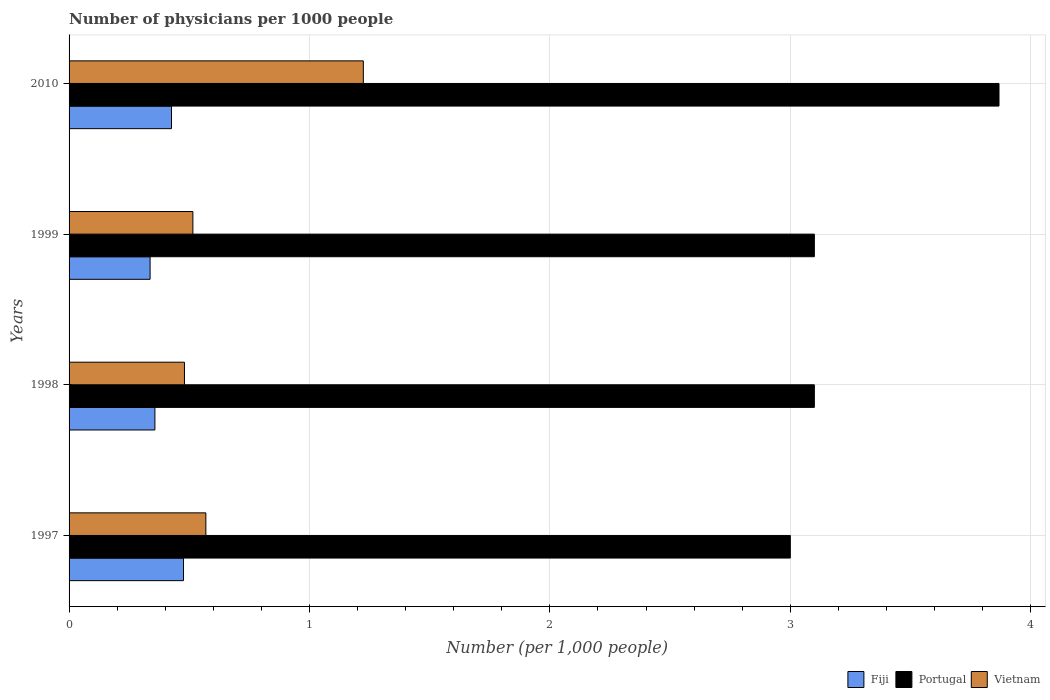How many bars are there on the 4th tick from the top?
Provide a succinct answer. 3. What is the label of the 3rd group of bars from the top?
Your answer should be compact. 1998. In how many cases, is the number of bars for a given year not equal to the number of legend labels?
Give a very brief answer. 0. What is the number of physicians in Vietnam in 2010?
Offer a very short reply. 1.22. Across all years, what is the maximum number of physicians in Portugal?
Your response must be concise. 3.87. Across all years, what is the minimum number of physicians in Fiji?
Your answer should be very brief. 0.34. In which year was the number of physicians in Portugal maximum?
Provide a succinct answer. 2010. What is the total number of physicians in Vietnam in the graph?
Keep it short and to the point. 2.79. What is the difference between the number of physicians in Fiji in 1999 and that in 2010?
Keep it short and to the point. -0.09. What is the difference between the number of physicians in Portugal in 1998 and the number of physicians in Fiji in 1999?
Provide a short and direct response. 2.76. What is the average number of physicians in Vietnam per year?
Provide a succinct answer. 0.7. In the year 2010, what is the difference between the number of physicians in Portugal and number of physicians in Fiji?
Provide a succinct answer. 3.44. What is the ratio of the number of physicians in Fiji in 1997 to that in 2010?
Give a very brief answer. 1.12. Is the number of physicians in Portugal in 1998 less than that in 2010?
Your answer should be very brief. Yes. What is the difference between the highest and the second highest number of physicians in Fiji?
Make the answer very short. 0.05. What is the difference between the highest and the lowest number of physicians in Portugal?
Your answer should be very brief. 0.87. Is the sum of the number of physicians in Vietnam in 1998 and 2010 greater than the maximum number of physicians in Portugal across all years?
Keep it short and to the point. No. What does the 3rd bar from the top in 1999 represents?
Offer a terse response. Fiji. What does the 1st bar from the bottom in 1999 represents?
Provide a succinct answer. Fiji. Is it the case that in every year, the sum of the number of physicians in Fiji and number of physicians in Vietnam is greater than the number of physicians in Portugal?
Keep it short and to the point. No. How many bars are there?
Provide a short and direct response. 12. What is the difference between two consecutive major ticks on the X-axis?
Provide a succinct answer. 1. Where does the legend appear in the graph?
Your answer should be very brief. Bottom right. What is the title of the graph?
Give a very brief answer. Number of physicians per 1000 people. Does "Latvia" appear as one of the legend labels in the graph?
Offer a very short reply. No. What is the label or title of the X-axis?
Keep it short and to the point. Number (per 1,0 people). What is the label or title of the Y-axis?
Keep it short and to the point. Years. What is the Number (per 1,000 people) of Fiji in 1997?
Provide a succinct answer. 0.48. What is the Number (per 1,000 people) of Portugal in 1997?
Offer a terse response. 3. What is the Number (per 1,000 people) of Vietnam in 1997?
Provide a short and direct response. 0.57. What is the Number (per 1,000 people) in Fiji in 1998?
Provide a short and direct response. 0.36. What is the Number (per 1,000 people) of Portugal in 1998?
Ensure brevity in your answer.  3.1. What is the Number (per 1,000 people) of Vietnam in 1998?
Make the answer very short. 0.48. What is the Number (per 1,000 people) in Fiji in 1999?
Your answer should be compact. 0.34. What is the Number (per 1,000 people) in Portugal in 1999?
Offer a very short reply. 3.1. What is the Number (per 1,000 people) of Vietnam in 1999?
Offer a very short reply. 0.52. What is the Number (per 1,000 people) of Fiji in 2010?
Ensure brevity in your answer.  0.43. What is the Number (per 1,000 people) of Portugal in 2010?
Make the answer very short. 3.87. What is the Number (per 1,000 people) in Vietnam in 2010?
Your answer should be compact. 1.22. Across all years, what is the maximum Number (per 1,000 people) in Fiji?
Keep it short and to the point. 0.48. Across all years, what is the maximum Number (per 1,000 people) of Portugal?
Your answer should be very brief. 3.87. Across all years, what is the maximum Number (per 1,000 people) in Vietnam?
Make the answer very short. 1.22. Across all years, what is the minimum Number (per 1,000 people) in Fiji?
Give a very brief answer. 0.34. Across all years, what is the minimum Number (per 1,000 people) of Vietnam?
Give a very brief answer. 0.48. What is the total Number (per 1,000 people) in Fiji in the graph?
Offer a terse response. 1.6. What is the total Number (per 1,000 people) of Portugal in the graph?
Ensure brevity in your answer.  13.07. What is the total Number (per 1,000 people) in Vietnam in the graph?
Provide a succinct answer. 2.79. What is the difference between the Number (per 1,000 people) in Fiji in 1997 and that in 1998?
Make the answer very short. 0.12. What is the difference between the Number (per 1,000 people) of Vietnam in 1997 and that in 1998?
Keep it short and to the point. 0.09. What is the difference between the Number (per 1,000 people) in Fiji in 1997 and that in 1999?
Ensure brevity in your answer.  0.14. What is the difference between the Number (per 1,000 people) in Vietnam in 1997 and that in 1999?
Ensure brevity in your answer.  0.05. What is the difference between the Number (per 1,000 people) of Portugal in 1997 and that in 2010?
Provide a succinct answer. -0.87. What is the difference between the Number (per 1,000 people) in Vietnam in 1997 and that in 2010?
Make the answer very short. -0.66. What is the difference between the Number (per 1,000 people) in Portugal in 1998 and that in 1999?
Keep it short and to the point. 0. What is the difference between the Number (per 1,000 people) in Vietnam in 1998 and that in 1999?
Offer a very short reply. -0.04. What is the difference between the Number (per 1,000 people) of Fiji in 1998 and that in 2010?
Ensure brevity in your answer.  -0.07. What is the difference between the Number (per 1,000 people) in Portugal in 1998 and that in 2010?
Ensure brevity in your answer.  -0.77. What is the difference between the Number (per 1,000 people) in Vietnam in 1998 and that in 2010?
Your answer should be compact. -0.74. What is the difference between the Number (per 1,000 people) of Fiji in 1999 and that in 2010?
Your answer should be very brief. -0.09. What is the difference between the Number (per 1,000 people) of Portugal in 1999 and that in 2010?
Make the answer very short. -0.77. What is the difference between the Number (per 1,000 people) in Vietnam in 1999 and that in 2010?
Offer a terse response. -0.71. What is the difference between the Number (per 1,000 people) in Fiji in 1997 and the Number (per 1,000 people) in Portugal in 1998?
Make the answer very short. -2.62. What is the difference between the Number (per 1,000 people) in Fiji in 1997 and the Number (per 1,000 people) in Vietnam in 1998?
Your answer should be compact. -0. What is the difference between the Number (per 1,000 people) in Portugal in 1997 and the Number (per 1,000 people) in Vietnam in 1998?
Your response must be concise. 2.52. What is the difference between the Number (per 1,000 people) of Fiji in 1997 and the Number (per 1,000 people) of Portugal in 1999?
Keep it short and to the point. -2.62. What is the difference between the Number (per 1,000 people) of Fiji in 1997 and the Number (per 1,000 people) of Vietnam in 1999?
Ensure brevity in your answer.  -0.04. What is the difference between the Number (per 1,000 people) of Portugal in 1997 and the Number (per 1,000 people) of Vietnam in 1999?
Offer a very short reply. 2.48. What is the difference between the Number (per 1,000 people) in Fiji in 1997 and the Number (per 1,000 people) in Portugal in 2010?
Make the answer very short. -3.39. What is the difference between the Number (per 1,000 people) in Fiji in 1997 and the Number (per 1,000 people) in Vietnam in 2010?
Keep it short and to the point. -0.75. What is the difference between the Number (per 1,000 people) in Portugal in 1997 and the Number (per 1,000 people) in Vietnam in 2010?
Keep it short and to the point. 1.78. What is the difference between the Number (per 1,000 people) of Fiji in 1998 and the Number (per 1,000 people) of Portugal in 1999?
Offer a terse response. -2.74. What is the difference between the Number (per 1,000 people) of Fiji in 1998 and the Number (per 1,000 people) of Vietnam in 1999?
Offer a terse response. -0.16. What is the difference between the Number (per 1,000 people) of Portugal in 1998 and the Number (per 1,000 people) of Vietnam in 1999?
Provide a short and direct response. 2.58. What is the difference between the Number (per 1,000 people) of Fiji in 1998 and the Number (per 1,000 people) of Portugal in 2010?
Provide a short and direct response. -3.51. What is the difference between the Number (per 1,000 people) of Fiji in 1998 and the Number (per 1,000 people) of Vietnam in 2010?
Offer a terse response. -0.87. What is the difference between the Number (per 1,000 people) in Portugal in 1998 and the Number (per 1,000 people) in Vietnam in 2010?
Make the answer very short. 1.88. What is the difference between the Number (per 1,000 people) of Fiji in 1999 and the Number (per 1,000 people) of Portugal in 2010?
Offer a terse response. -3.53. What is the difference between the Number (per 1,000 people) of Fiji in 1999 and the Number (per 1,000 people) of Vietnam in 2010?
Offer a terse response. -0.89. What is the difference between the Number (per 1,000 people) in Portugal in 1999 and the Number (per 1,000 people) in Vietnam in 2010?
Your answer should be very brief. 1.88. What is the average Number (per 1,000 people) of Fiji per year?
Keep it short and to the point. 0.4. What is the average Number (per 1,000 people) of Portugal per year?
Your answer should be very brief. 3.27. What is the average Number (per 1,000 people) of Vietnam per year?
Your answer should be very brief. 0.7. In the year 1997, what is the difference between the Number (per 1,000 people) in Fiji and Number (per 1,000 people) in Portugal?
Keep it short and to the point. -2.52. In the year 1997, what is the difference between the Number (per 1,000 people) of Fiji and Number (per 1,000 people) of Vietnam?
Provide a short and direct response. -0.09. In the year 1997, what is the difference between the Number (per 1,000 people) in Portugal and Number (per 1,000 people) in Vietnam?
Your answer should be compact. 2.43. In the year 1998, what is the difference between the Number (per 1,000 people) in Fiji and Number (per 1,000 people) in Portugal?
Give a very brief answer. -2.74. In the year 1998, what is the difference between the Number (per 1,000 people) of Fiji and Number (per 1,000 people) of Vietnam?
Your response must be concise. -0.12. In the year 1998, what is the difference between the Number (per 1,000 people) of Portugal and Number (per 1,000 people) of Vietnam?
Keep it short and to the point. 2.62. In the year 1999, what is the difference between the Number (per 1,000 people) of Fiji and Number (per 1,000 people) of Portugal?
Provide a succinct answer. -2.76. In the year 1999, what is the difference between the Number (per 1,000 people) of Fiji and Number (per 1,000 people) of Vietnam?
Provide a short and direct response. -0.18. In the year 1999, what is the difference between the Number (per 1,000 people) in Portugal and Number (per 1,000 people) in Vietnam?
Offer a terse response. 2.58. In the year 2010, what is the difference between the Number (per 1,000 people) of Fiji and Number (per 1,000 people) of Portugal?
Give a very brief answer. -3.44. In the year 2010, what is the difference between the Number (per 1,000 people) of Fiji and Number (per 1,000 people) of Vietnam?
Your answer should be compact. -0.8. In the year 2010, what is the difference between the Number (per 1,000 people) in Portugal and Number (per 1,000 people) in Vietnam?
Provide a short and direct response. 2.64. What is the ratio of the Number (per 1,000 people) of Vietnam in 1997 to that in 1998?
Make the answer very short. 1.19. What is the ratio of the Number (per 1,000 people) in Fiji in 1997 to that in 1999?
Offer a terse response. 1.41. What is the ratio of the Number (per 1,000 people) in Portugal in 1997 to that in 1999?
Offer a very short reply. 0.97. What is the ratio of the Number (per 1,000 people) of Vietnam in 1997 to that in 1999?
Make the answer very short. 1.1. What is the ratio of the Number (per 1,000 people) in Fiji in 1997 to that in 2010?
Keep it short and to the point. 1.12. What is the ratio of the Number (per 1,000 people) of Portugal in 1997 to that in 2010?
Your answer should be compact. 0.78. What is the ratio of the Number (per 1,000 people) of Vietnam in 1997 to that in 2010?
Offer a terse response. 0.46. What is the ratio of the Number (per 1,000 people) of Fiji in 1998 to that in 1999?
Provide a succinct answer. 1.06. What is the ratio of the Number (per 1,000 people) in Portugal in 1998 to that in 1999?
Your answer should be very brief. 1. What is the ratio of the Number (per 1,000 people) of Vietnam in 1998 to that in 1999?
Offer a very short reply. 0.93. What is the ratio of the Number (per 1,000 people) in Fiji in 1998 to that in 2010?
Offer a very short reply. 0.84. What is the ratio of the Number (per 1,000 people) of Portugal in 1998 to that in 2010?
Your answer should be compact. 0.8. What is the ratio of the Number (per 1,000 people) in Vietnam in 1998 to that in 2010?
Offer a very short reply. 0.39. What is the ratio of the Number (per 1,000 people) in Fiji in 1999 to that in 2010?
Provide a succinct answer. 0.79. What is the ratio of the Number (per 1,000 people) of Portugal in 1999 to that in 2010?
Offer a terse response. 0.8. What is the ratio of the Number (per 1,000 people) in Vietnam in 1999 to that in 2010?
Your answer should be very brief. 0.42. What is the difference between the highest and the second highest Number (per 1,000 people) of Portugal?
Your response must be concise. 0.77. What is the difference between the highest and the second highest Number (per 1,000 people) in Vietnam?
Give a very brief answer. 0.66. What is the difference between the highest and the lowest Number (per 1,000 people) in Fiji?
Your answer should be compact. 0.14. What is the difference between the highest and the lowest Number (per 1,000 people) of Portugal?
Offer a terse response. 0.87. What is the difference between the highest and the lowest Number (per 1,000 people) of Vietnam?
Your answer should be compact. 0.74. 